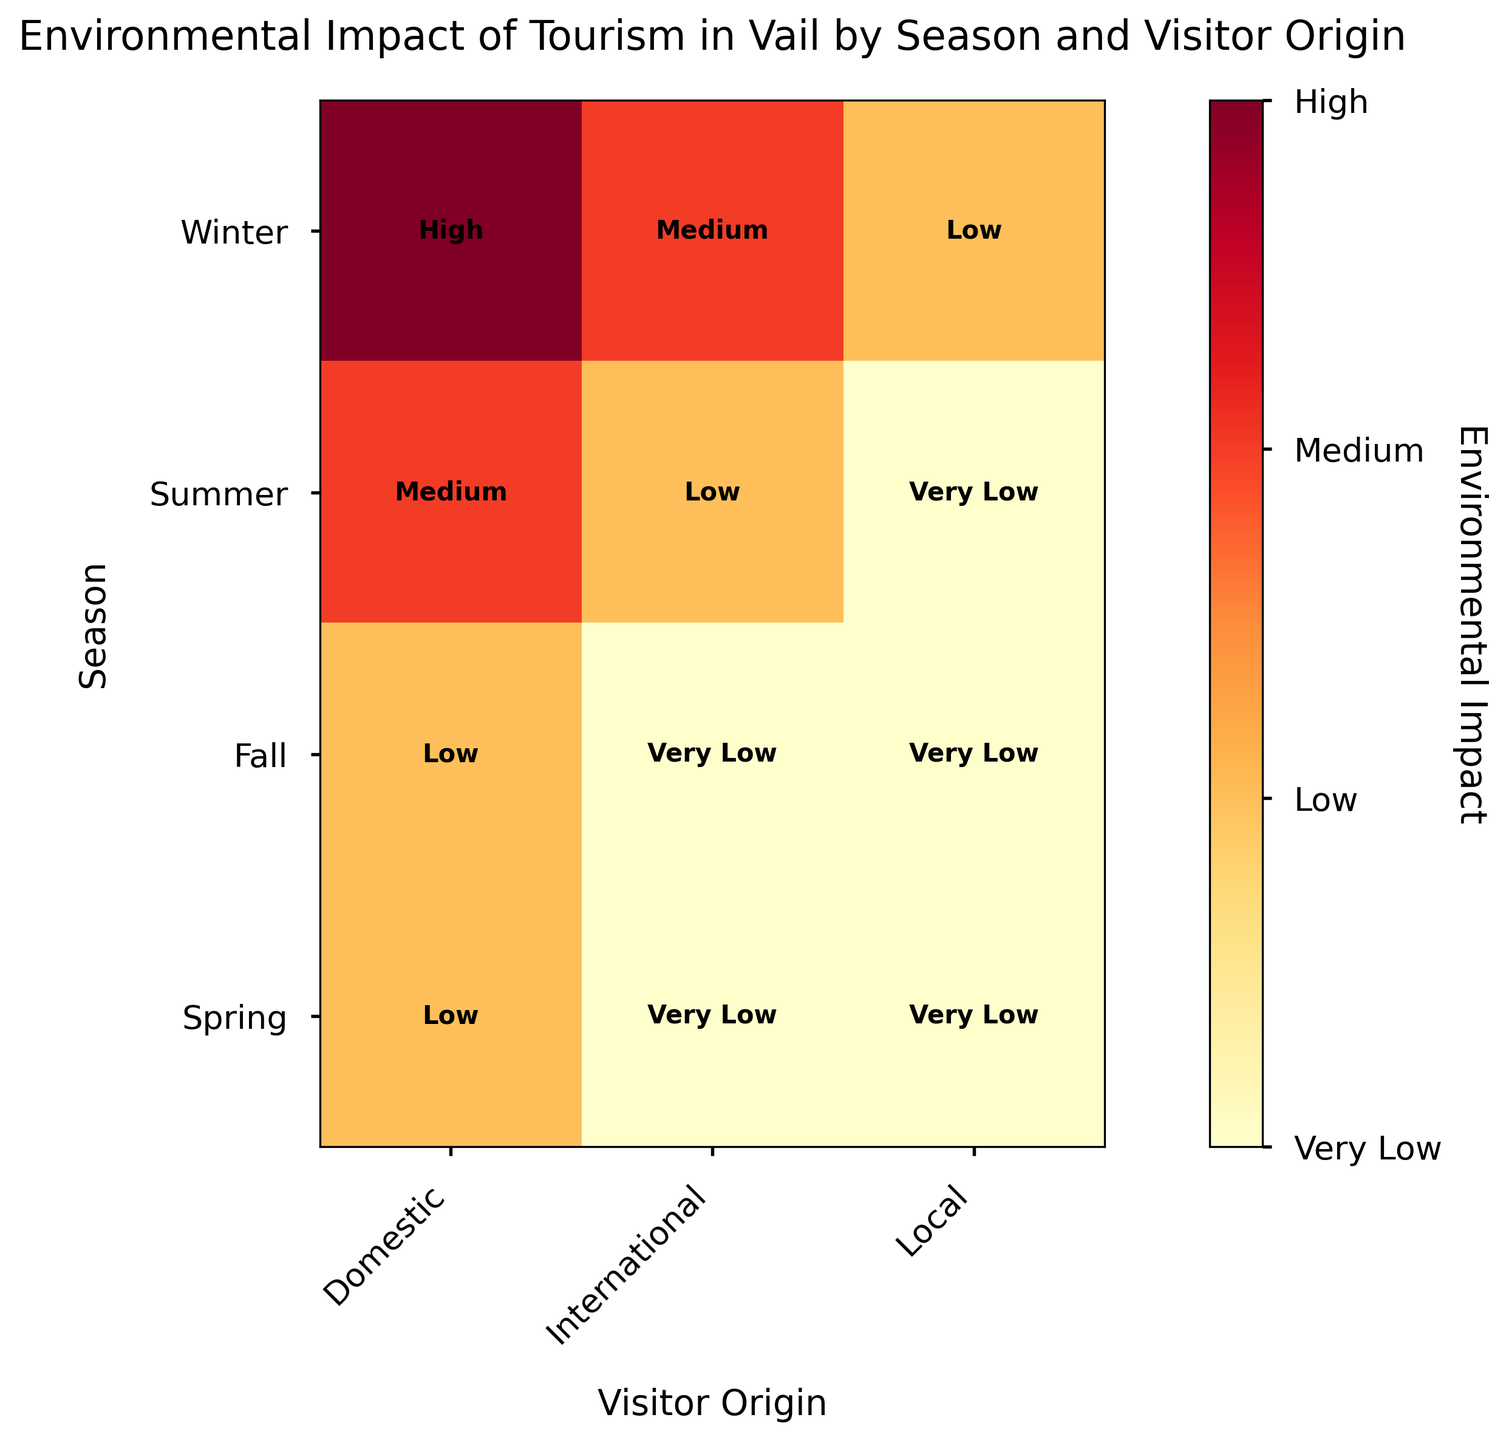Which season has the highest environmental impact from domestic visitors? The mosaic plot indicates that domestic visitors in winter have a high environmental impact, which is the highest rating on the scale.
Answer: Winter How does the environmental impact of international visitors in summer compare to that of local visitors in winter? According to the mosaic plot, international visitors in summer have low environmental impact, while local visitors in winter have a low environmental impact as well. So they both have low impact ratings.
Answer: Equal What is the lowest environmental impact level observed across all categories? The impact levels in the mosaic plot range from "Very Low" to "High". The lowest level observed is "Very Low".
Answer: Very Low Which season has the most variability in environmental impact based on visitor origin? Winter has the most variability in environmental impact, ranging from "High" (Domestic) to "Low" (Local), while other seasons either have multiple "Very Low" impacts or range from "Medium" to "Very Low".
Answer: Winter Are there any seasons where all visitor origins have the same environmental impact level? In both Spring and Fall, all visitor origins (Domestic, International, Local) have "Very Low" environmental impact levels shown in the mosaic plot.
Answer: Yes Which visitor origin consistently has the lowest environmental impact in every season? Local visitors consistently have the lowest environmental impact (either "Very Low" or "Low") in every season according to the mosaic plot.
Answer: Local What's the difference in environmental impact between domestic and international visitors in summer? In the summer season, the mosaic plot shows that the environmental impact for domestic visitors is "Medium" while for international visitors it is "Low".
Answer: Medium - Low Is there any season where international visitors have a higher environmental impact than local visitors? During the winter season, international visitors have a "Medium" impact while local visitors have a "Low" impact, making this the only season where international visitors have a higher impact.
Answer: Winter What is the average environmental impact level for domestic visitors across all seasons? The impact levels for domestic visitors across all seasons are: High (Winter), Medium (Summer), Low (Fall), and Low (Spring). Average is calculated as (High + Medium + Low + Low) / 4 impact levels. Converting impact levels to numeric values: (3 + 2 + 1 + 1) / 4 = 1.75, corresponding to "Low", if interpreted numerically.
Answer: Low 